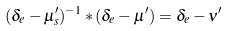<formula> <loc_0><loc_0><loc_500><loc_500>( \delta _ { e } - \mu ^ { \prime } _ { s } ) ^ { - 1 } \ast ( \delta _ { e } - \mu ^ { \prime } ) = \delta _ { e } - \nu ^ { \prime }</formula> 